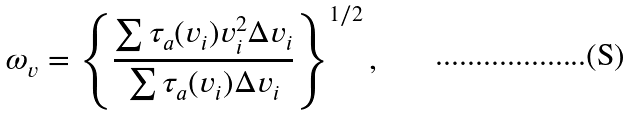<formula> <loc_0><loc_0><loc_500><loc_500>\omega _ { v } = \left \{ \frac { \sum \tau _ { a } ( v _ { i } ) v _ { i } ^ { 2 } \Delta v _ { i } } { \sum \tau _ { a } ( v _ { i } ) \Delta v _ { i } } \right \} ^ { 1 / 2 } ,</formula> 